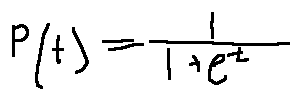<formula> <loc_0><loc_0><loc_500><loc_500>P ( t ) = \frac { 1 } { 1 + e ^ { - t } }</formula> 